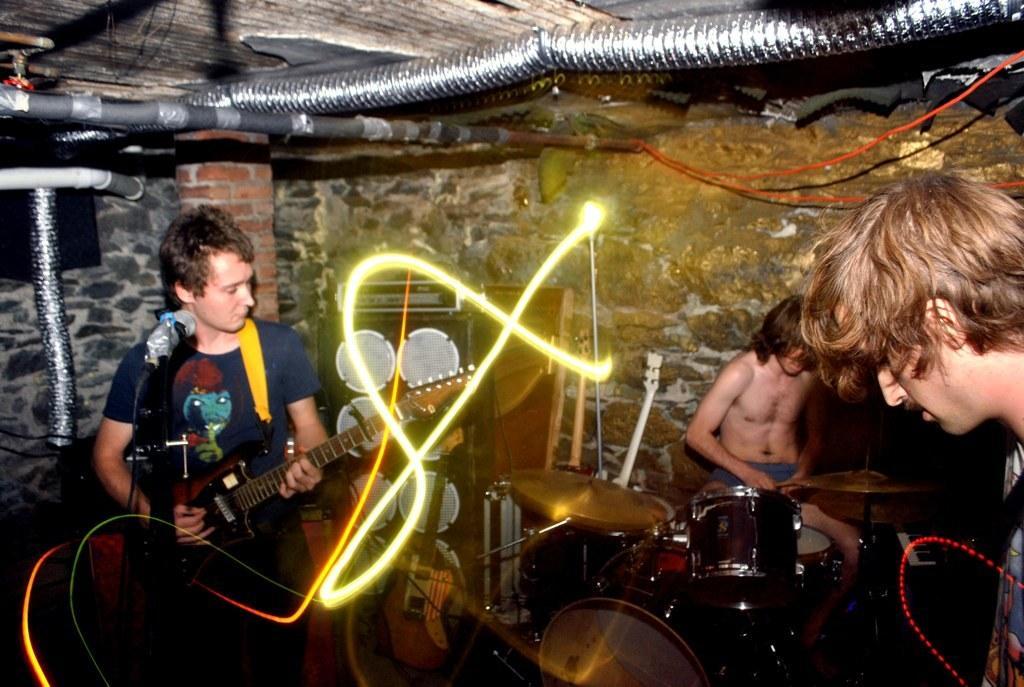Describe this image in one or two sentences. In this image I see 3 men, in which these 2 are standing and this man is sitting, I see that these both are near the musical instrument and he is standing in front of a mic. In the background I see the wall, pipes and a light over here and I can also see few equipment. 